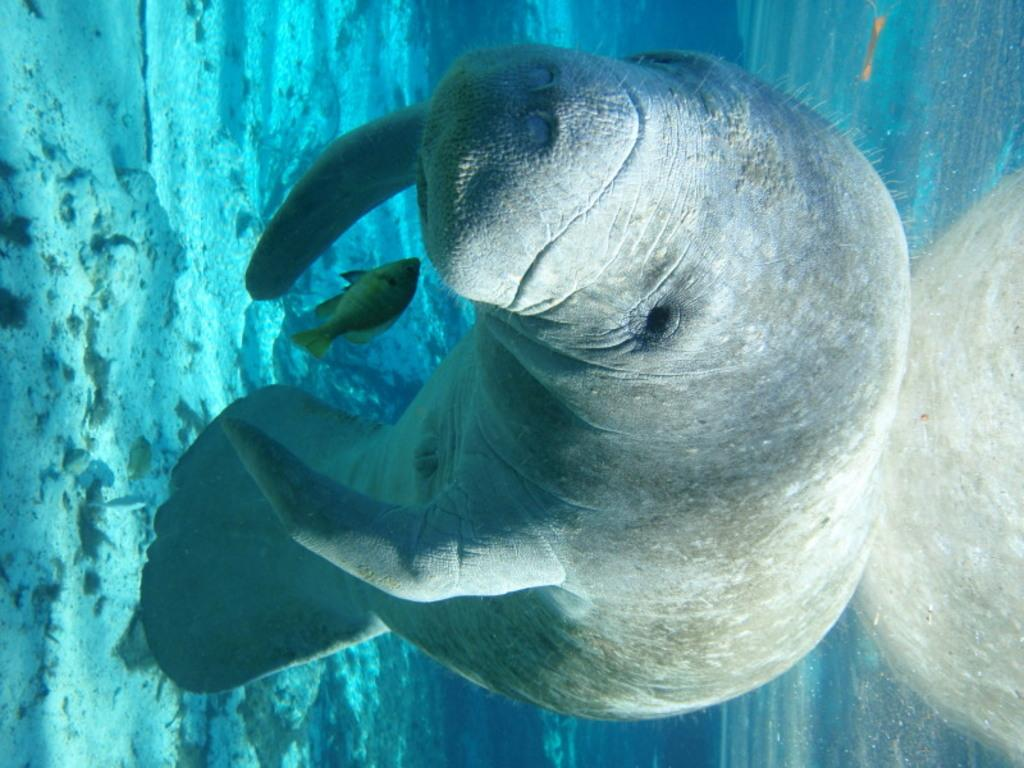What type of animal is in the image? There is a seal in the image. What is the seal interacting with in the image? There is a fish in the image, which the seal may be interacting with. What is the environment like in the image? There is water visible in the image, suggesting that the scene takes place near or in a body of water. What can be seen on the ground in the image? There is ground with some objects in the image, but the specific objects are not mentioned in the facts. What is located on the right side of the image? There is an object on the right side of the image, but the specific object is not mentioned in the facts. What type of exchange is taking place between the seal and the fish in the image? There is no exchange taking place between the seal and the fish in the image; the seal may be interacting with the fish, but the nature of that interaction is not specified. 